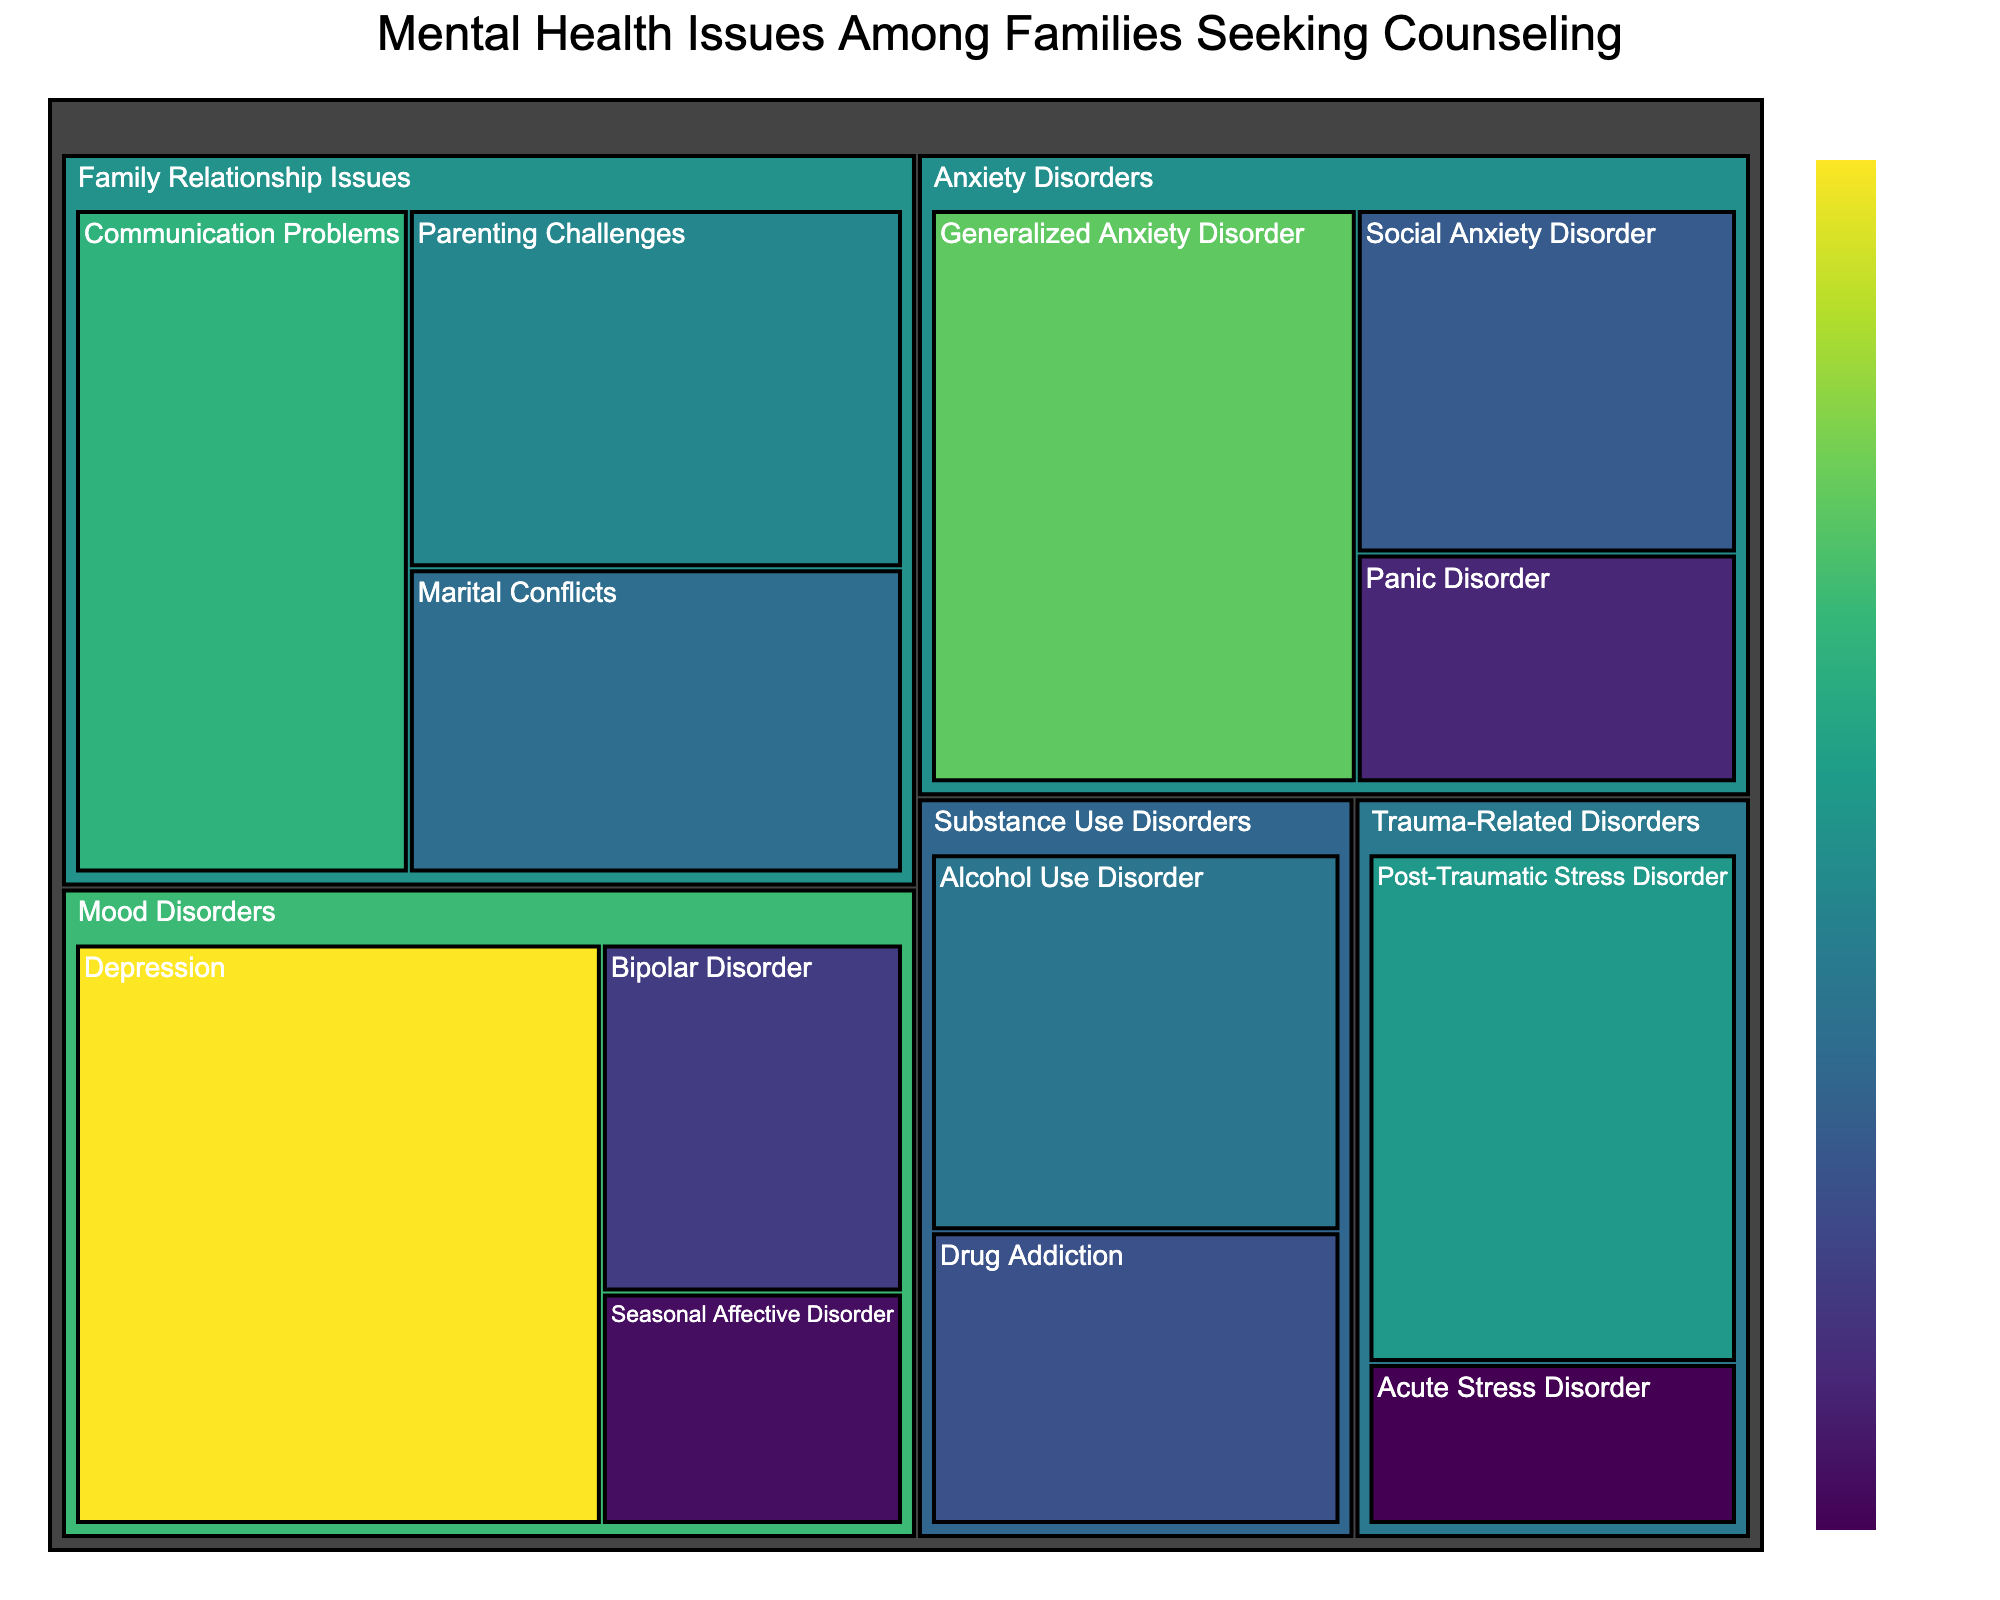What is the title of the Treemap? The title is shown at the top of the Treemap and provides a general idea of what the visualization is about.
Answer: Mental Health Issues Among Families Seeking Counseling Which subcategory has the highest value under Mood Disorders? By looking at the 'Mood Disorders' category and comparing the subcategories, you can see which has the largest area in the Treemap.
Answer: Depression How many subcategories are there in total under Anxiety Disorders? Counting the distinct subcategories shown under 'Anxiety Disorders' will give the number.
Answer: 3 Which family relationship issue has the lowest prevalence? Identify the subcategories under 'Family Relationship Issues' and compare their values.
Answer: Marital Conflicts What is the combined prevalence of all subcategories under Substance Use Disorders? Add the values for all the subcategories under 'Substance Use Disorders'. The values are 18 (Alcohol Use Disorder) and 14 (Drug Addiction). So, 18 + 14 = 32.
Answer: 32 Which category has the most subcategories? By comparing the number of subcategories under each main category.
Answer: Mood Disorders Which has a higher prevalence: Generalized Anxiety Disorder or Social Anxiety Disorder? Compare the values for 'Generalized Anxiety Disorder' (28) and 'Social Anxiety Disorder' (15) under 'Anxiety Disorders'. 28 is greater than 15.
Answer: Generalized Anxiety Disorder What is the sum of the prevalence values for all Family Relationship Issues? Add the values for all the subcategories under 'Family Relationship Issues': 25 (Communication Problems) + 20 (Parenting Challenges) + 17 (Marital Conflicts). So, 25 + 20 + 17 = 62.
Answer: 62 How does the prevalence of Post-Traumatic Stress Disorder compare to Acute Stress Disorder? Compare the values of both subcategories in 'Trauma-Related Disorders': 22 (Post-Traumatic Stress Disorder) and 7 (Acute Stress Disorder). 22 is greater than 7.
Answer: Post-Traumatic Stress Disorder has higher prevalence Which category has the lowest overall prevalence across its subcategories? Sum the prevalence values for each category and compare the totals. The category with the smallest sum is the answer. Substance Use Disorders: 18 + 14 = 32, Family Relationship Issues: 25 + 20 + 17 = 62, Trauma-Related Disorders: 22 + 7 = 29, Mood Disorders: 35 + 12 + 8 = 55, Anxiety Disorders: 28 + 15 + 10 = 53. The lowest is 'Trauma-Related Disorders' with 29.
Answer: Trauma-Related Disorders 